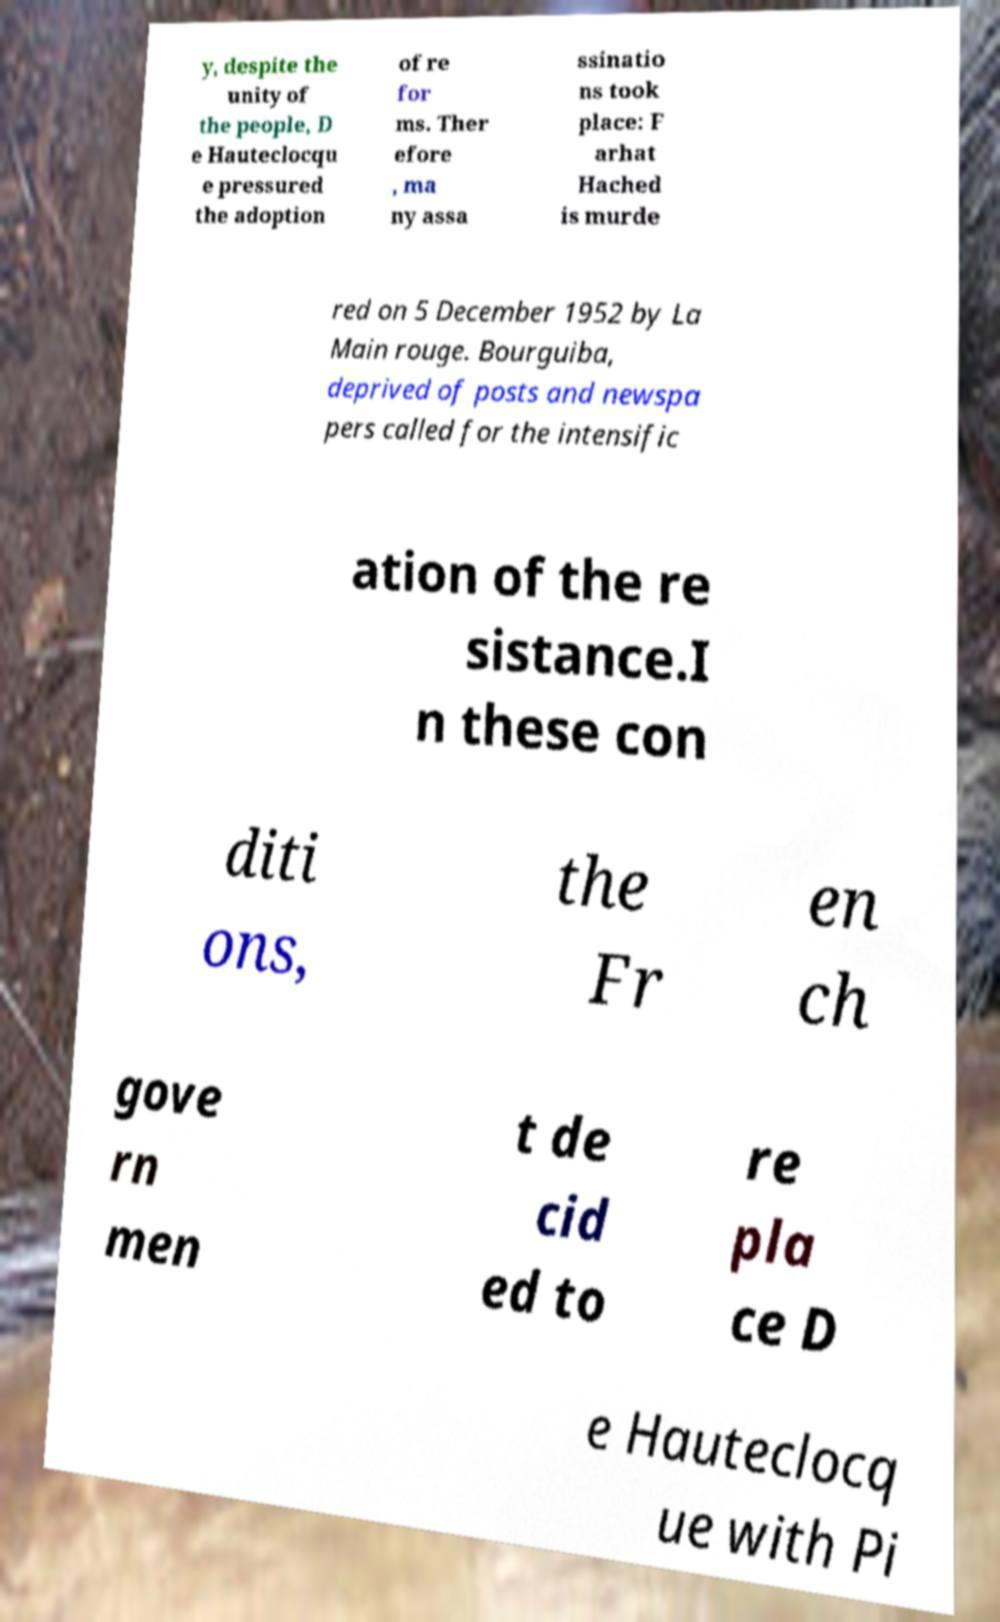Could you assist in decoding the text presented in this image and type it out clearly? y, despite the unity of the people, D e Hauteclocqu e pressured the adoption of re for ms. Ther efore , ma ny assa ssinatio ns took place: F arhat Hached is murde red on 5 December 1952 by La Main rouge. Bourguiba, deprived of posts and newspa pers called for the intensific ation of the re sistance.I n these con diti ons, the Fr en ch gove rn men t de cid ed to re pla ce D e Hauteclocq ue with Pi 